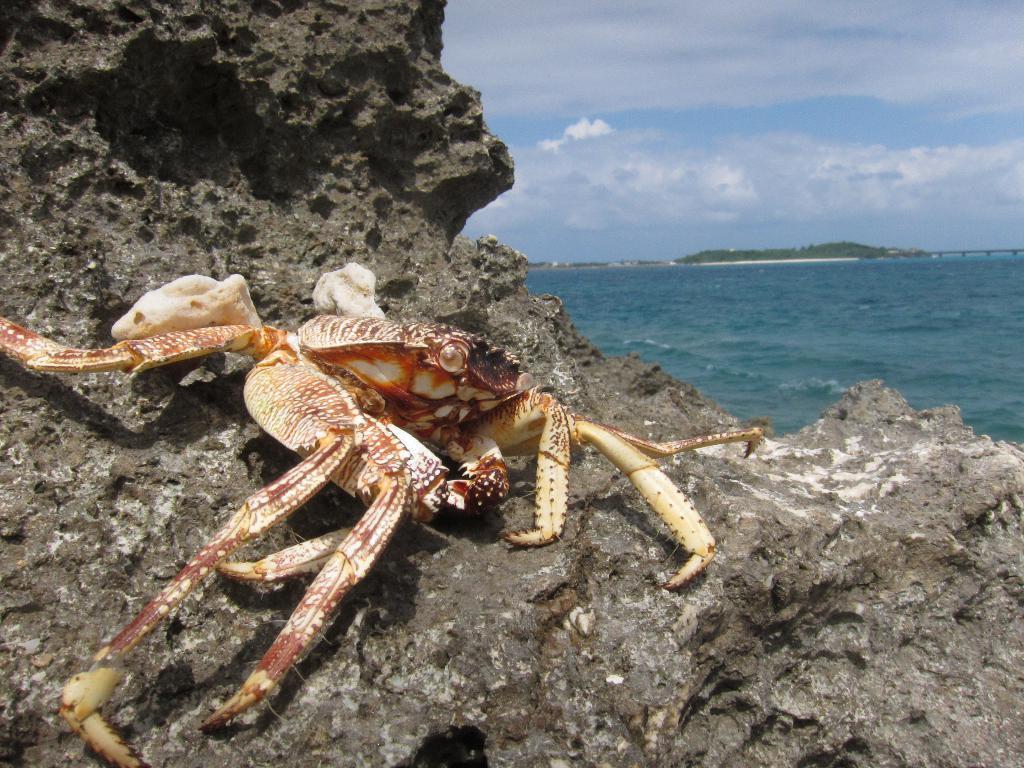Could you give a brief overview of what you see in this image? In this picture we can see a crab on a rock, water and in the background we can see the sky with clouds. 